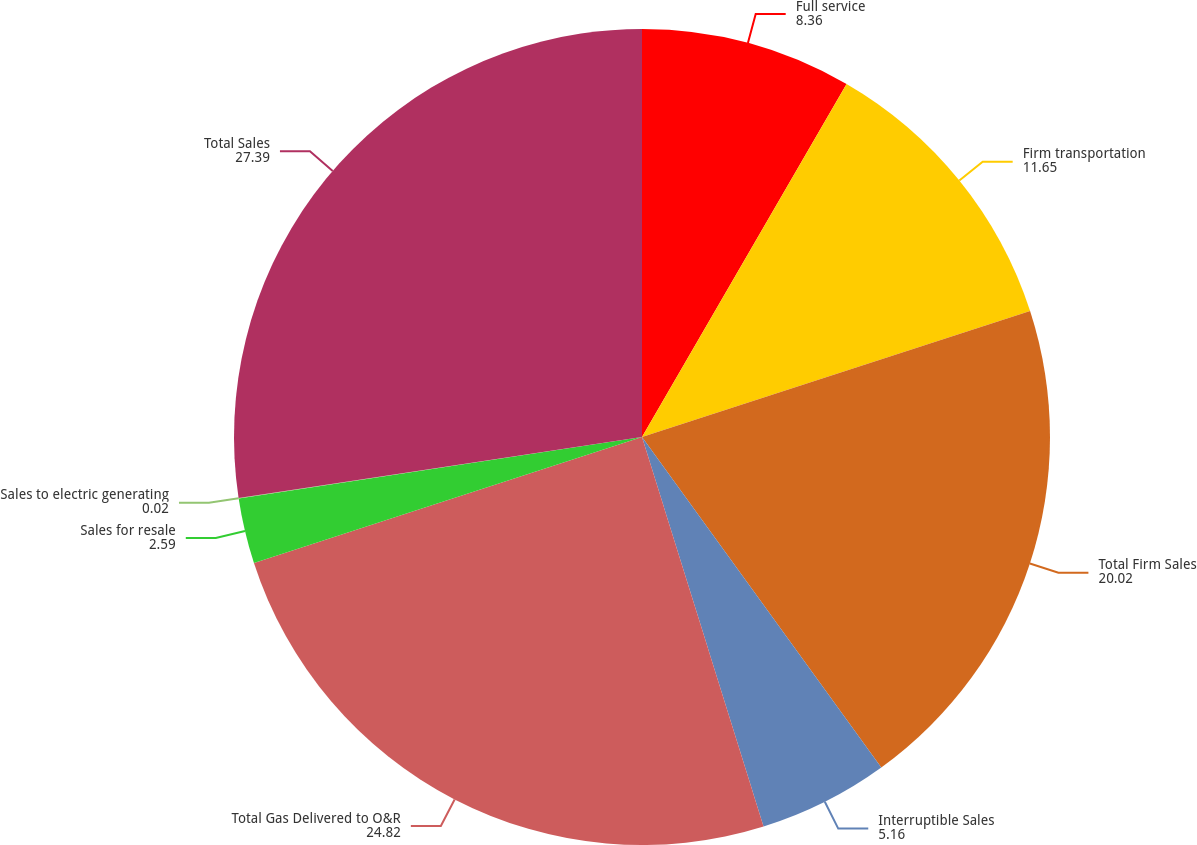<chart> <loc_0><loc_0><loc_500><loc_500><pie_chart><fcel>Full service<fcel>Firm transportation<fcel>Total Firm Sales<fcel>Interruptible Sales<fcel>Total Gas Delivered to O&R<fcel>Sales for resale<fcel>Sales to electric generating<fcel>Total Sales<nl><fcel>8.36%<fcel>11.65%<fcel>20.02%<fcel>5.16%<fcel>24.82%<fcel>2.59%<fcel>0.02%<fcel>27.39%<nl></chart> 